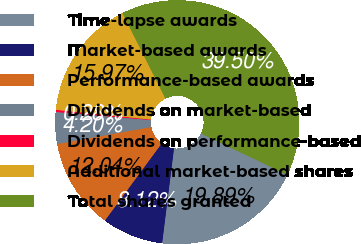Convert chart to OTSL. <chart><loc_0><loc_0><loc_500><loc_500><pie_chart><fcel>Time-lapse awards<fcel>Market-based awards<fcel>Performance-based awards<fcel>Dividends on market-based<fcel>Dividends on performance-based<fcel>Additional market-based shares<fcel>Total shares granted<nl><fcel>19.89%<fcel>8.12%<fcel>12.04%<fcel>4.2%<fcel>0.28%<fcel>15.97%<fcel>39.5%<nl></chart> 